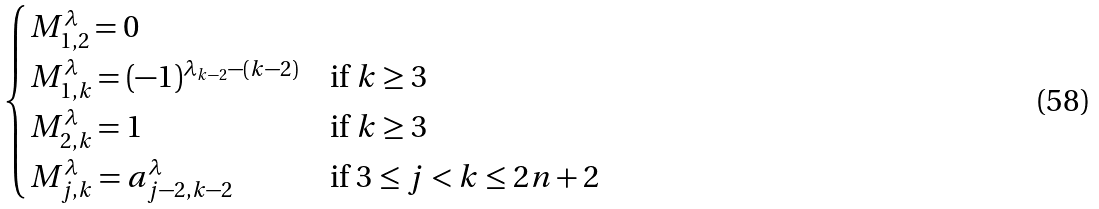Convert formula to latex. <formula><loc_0><loc_0><loc_500><loc_500>\begin{cases} M _ { 1 , 2 } ^ { \lambda } = 0 \\ M _ { 1 , k } ^ { \lambda } = ( - 1 ) ^ { \lambda _ { k - 2 } - ( k - 2 ) } & \text {if $k \geq 3$} \\ M _ { 2 , k } ^ { \lambda } = 1 & \text {if $k \geq 3$} \\ M _ { j , k } ^ { \lambda } = a _ { j - 2 , k - 2 } ^ { \lambda } & \text {if $3 \leq j<k \leq 2n+2$} \end{cases}</formula> 